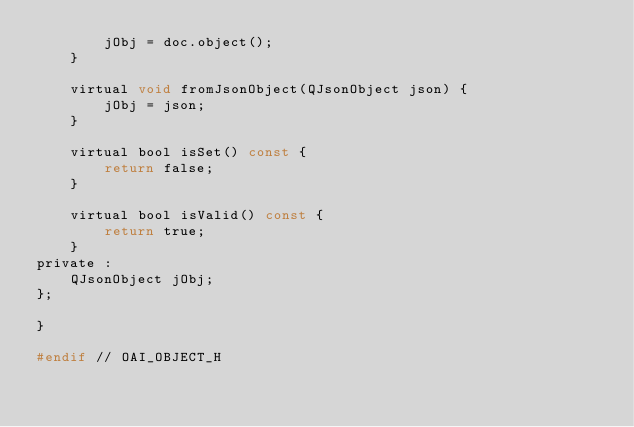<code> <loc_0><loc_0><loc_500><loc_500><_C_>        jObj = doc.object();
    }

    virtual void fromJsonObject(QJsonObject json) {
        jObj = json;
    }

    virtual bool isSet() const {
        return false;
    }

    virtual bool isValid() const {
        return true;
    }
private :
    QJsonObject jObj;
};

}

#endif // OAI_OBJECT_H
</code> 